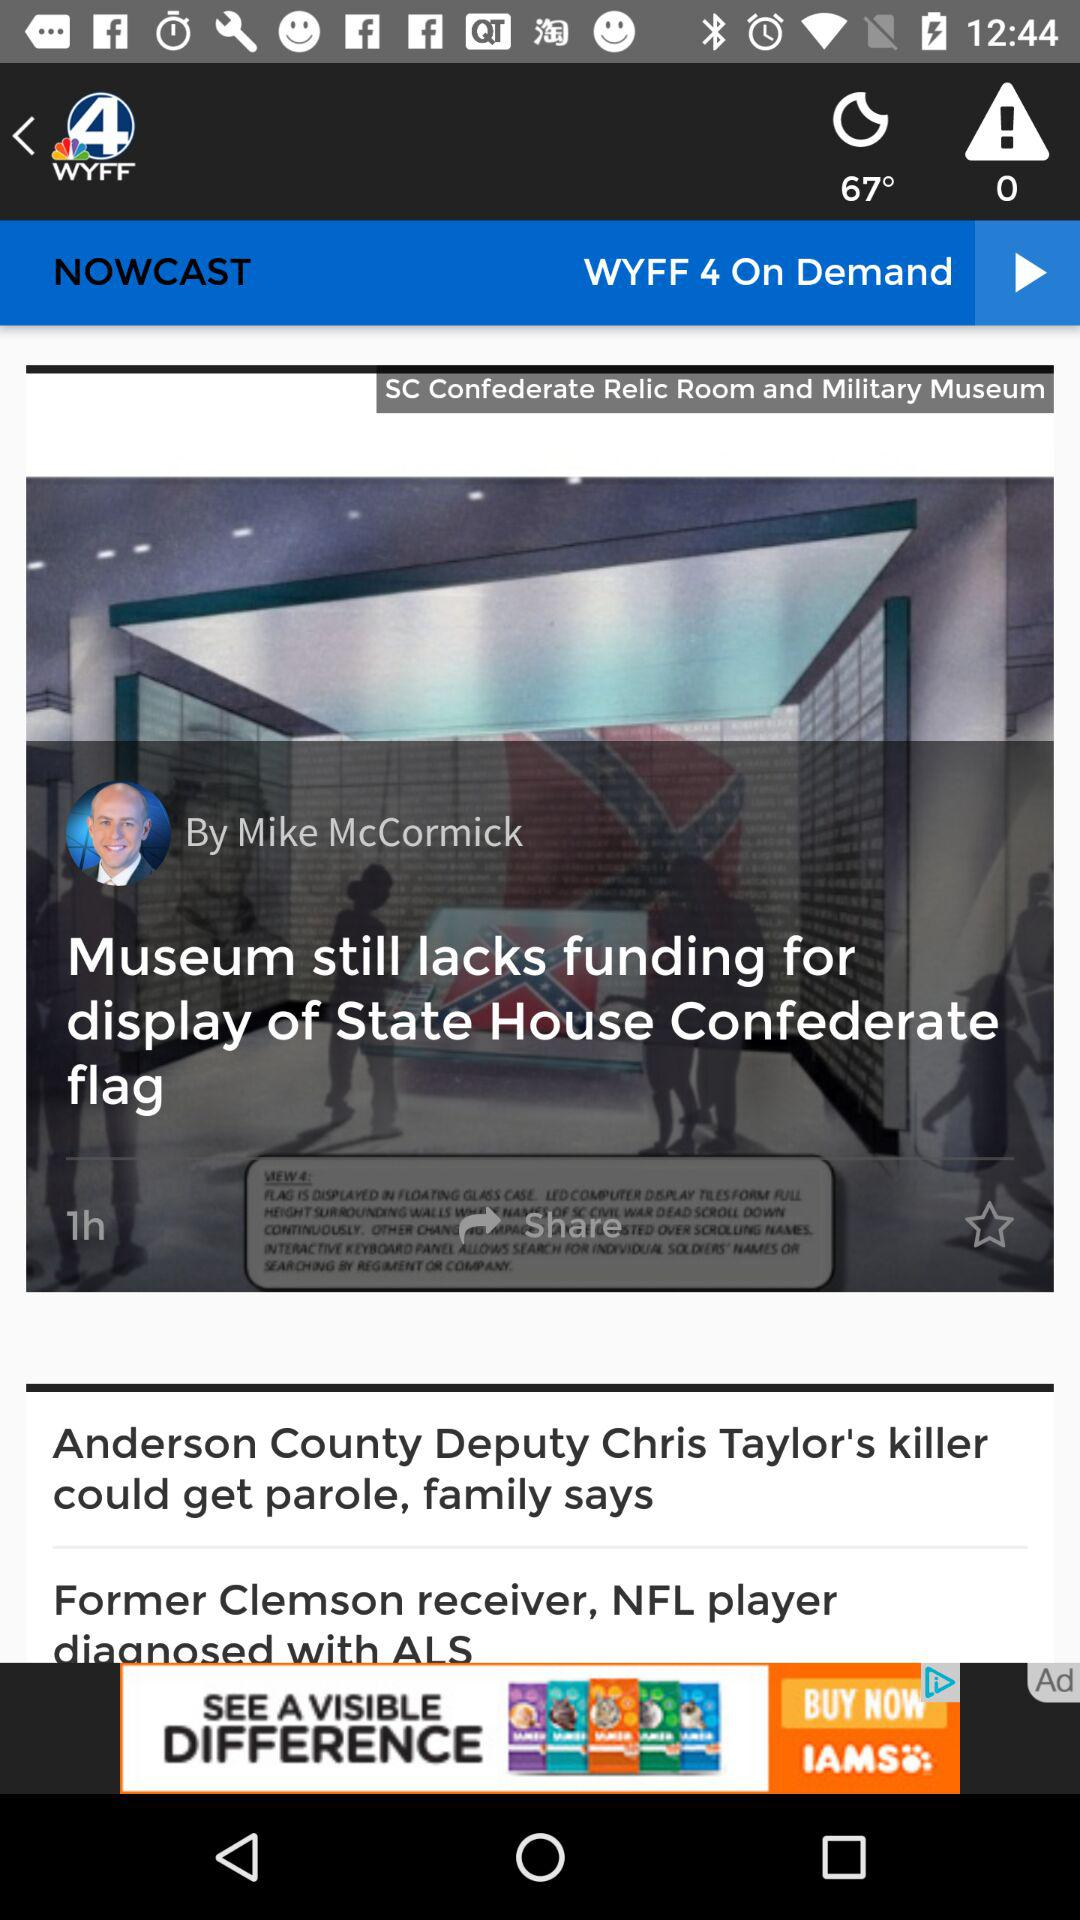What is the news station name? The news station name is "WYFF". 